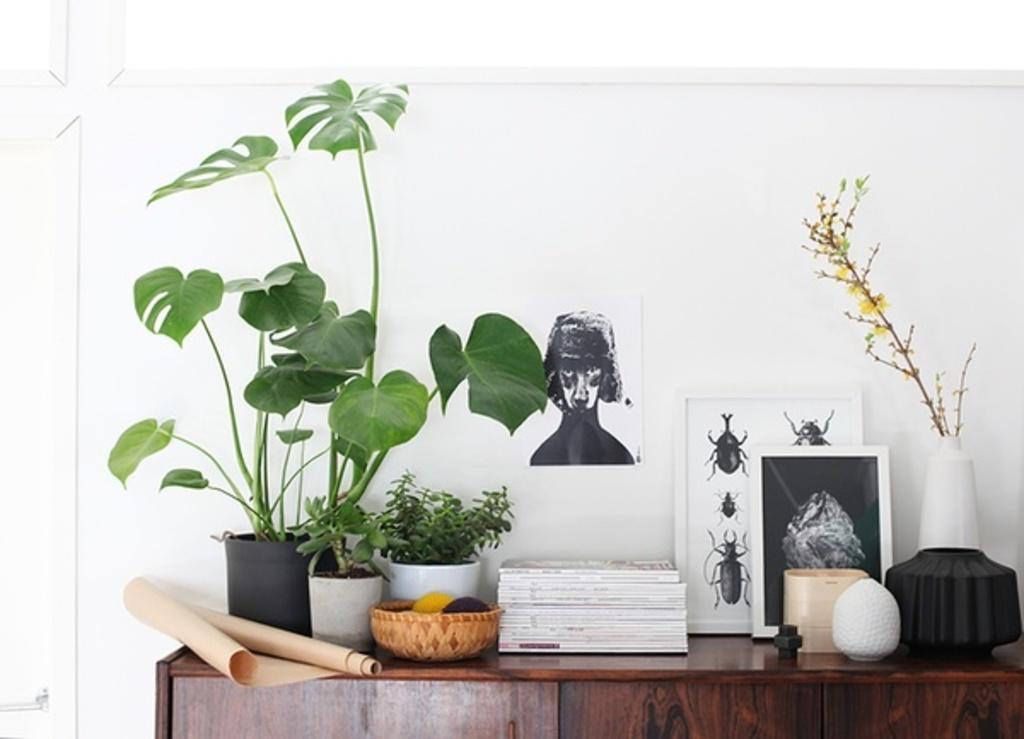What type of living organisms can be seen in the image? Plants are visible in the image. What items are used for displaying photographs in the image? There are photo frames in the image. What type of reading material can be seen in the image? Books are present in the image. What is the material used for writing or drawing in the image? There is paper in the image. What type of container is present in the image? There is a basket in the image. What objects are placed on a cupboard in the image? There are objects on a cupboard in the image. What is the location of the papers in the background of the image? Papers are stuck to the wall in the background of the image. Can you see the sea in the image? No, the sea is not present in the image. What type of root is growing from the plants in the image? There are no roots visible in the image, as the plants are likely potted or artificial. 